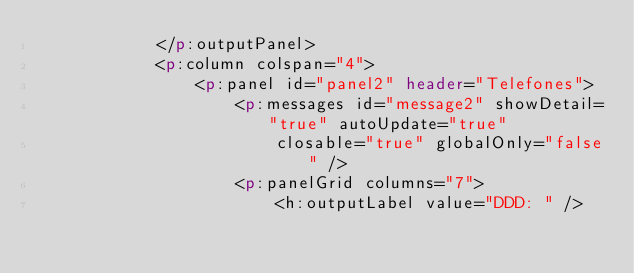Convert code to text. <code><loc_0><loc_0><loc_500><loc_500><_HTML_>			</p:outputPanel>
			<p:column colspan="4">
				<p:panel id="panel2" header="Telefones">
					<p:messages id="message2" showDetail="true" autoUpdate="true"
						closable="true" globalOnly="false" />
					<p:panelGrid columns="7">
						<h:outputLabel value="DDD: " /></code> 